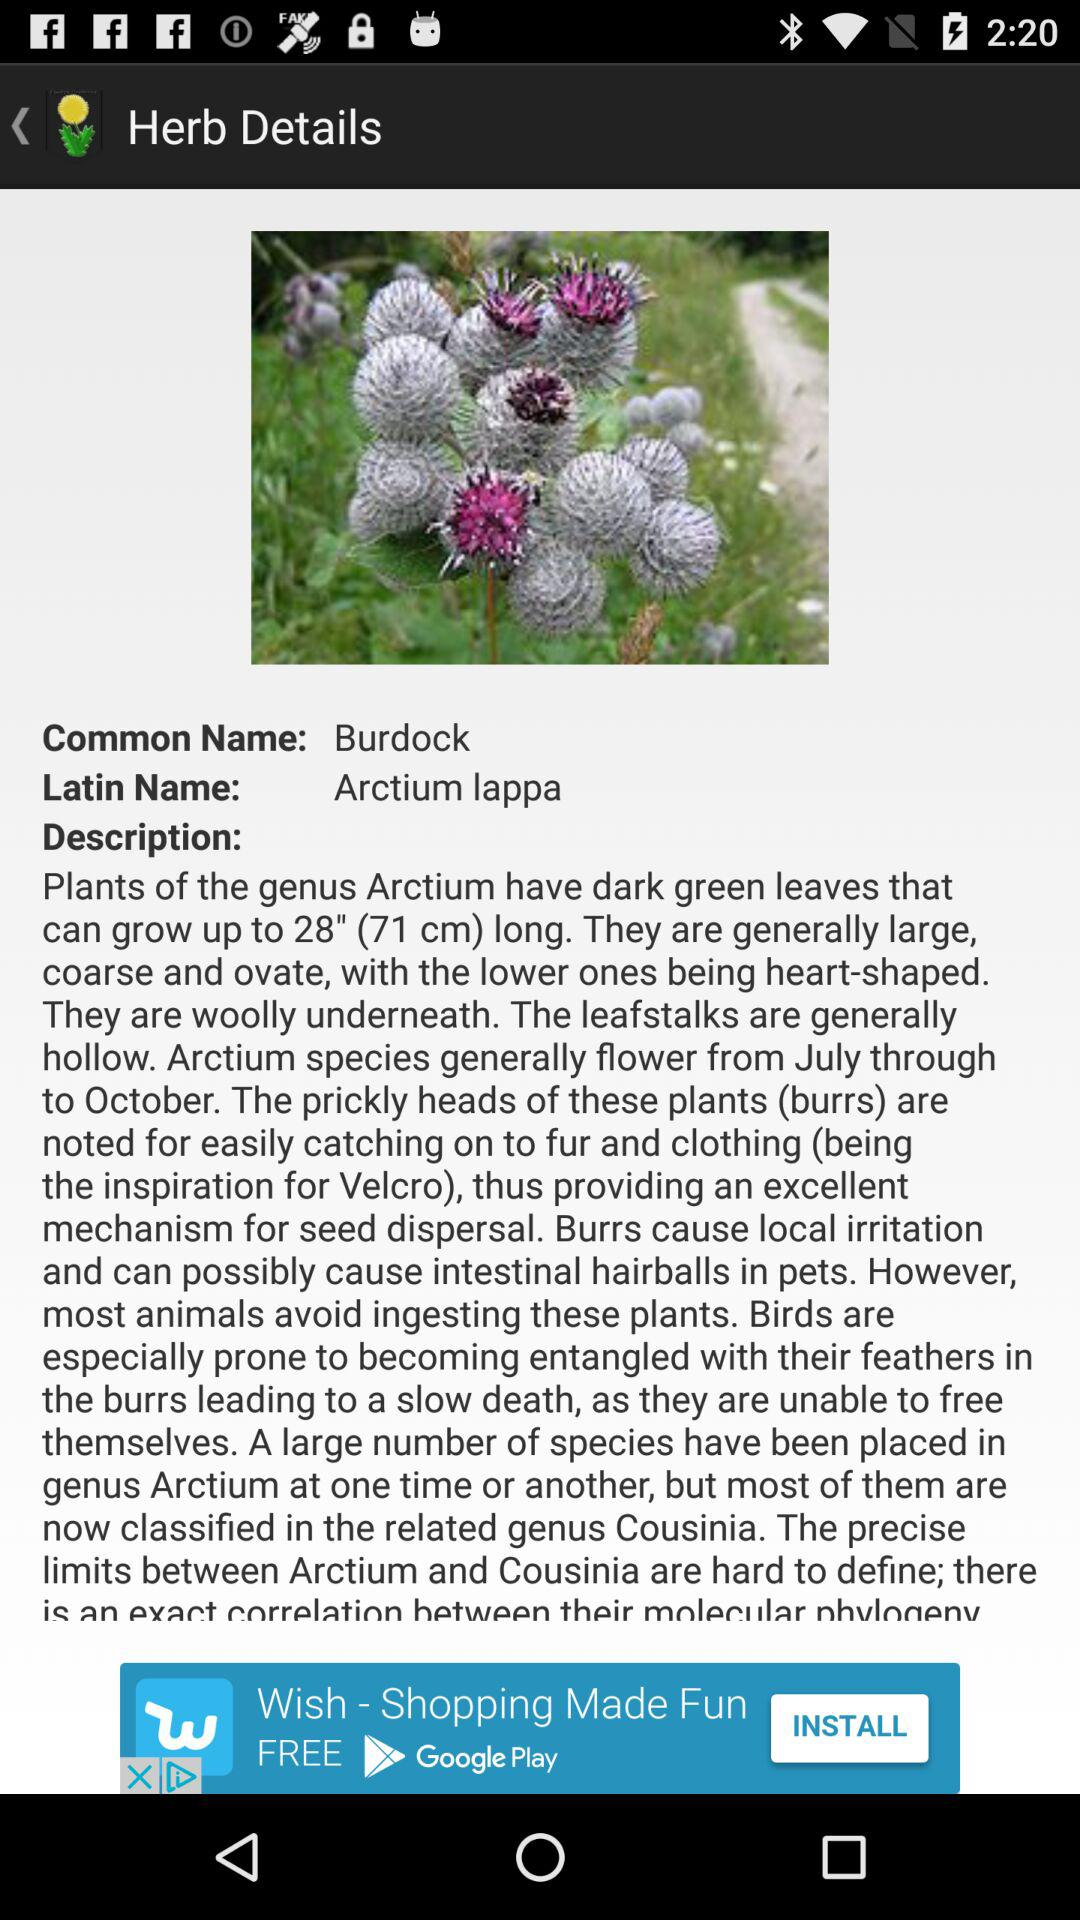What is the Latin name of this plant? The Latin name of this plant is "Arctium lappa". 